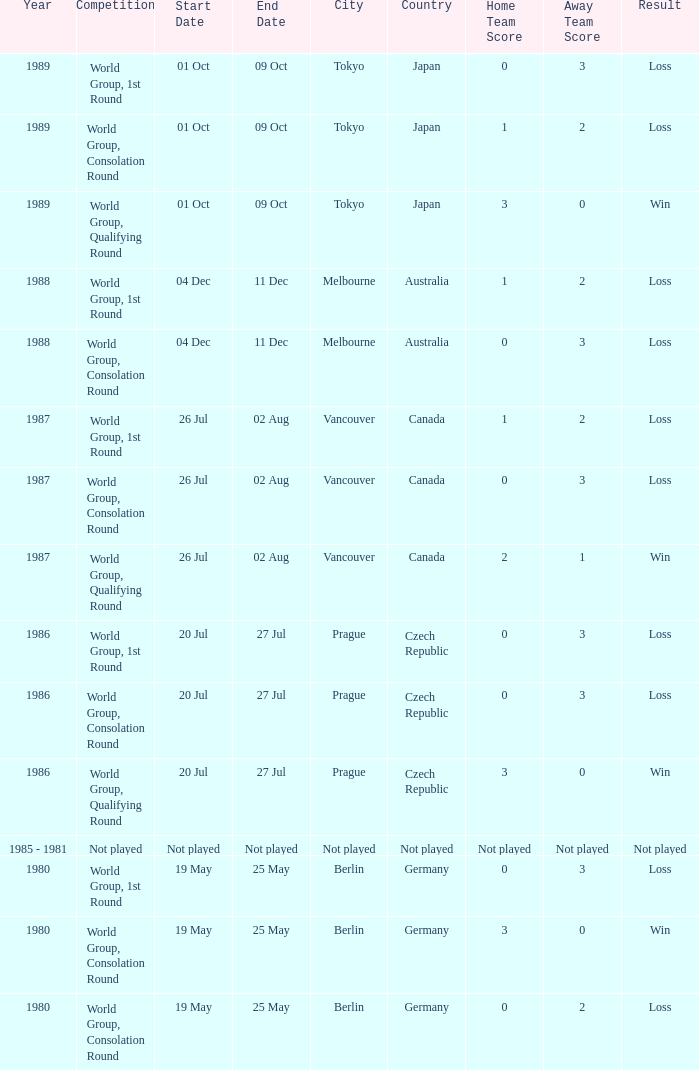What is the competition in tokyo with the result loss? World Group, 1st Round, World Group, Consolation Round. 